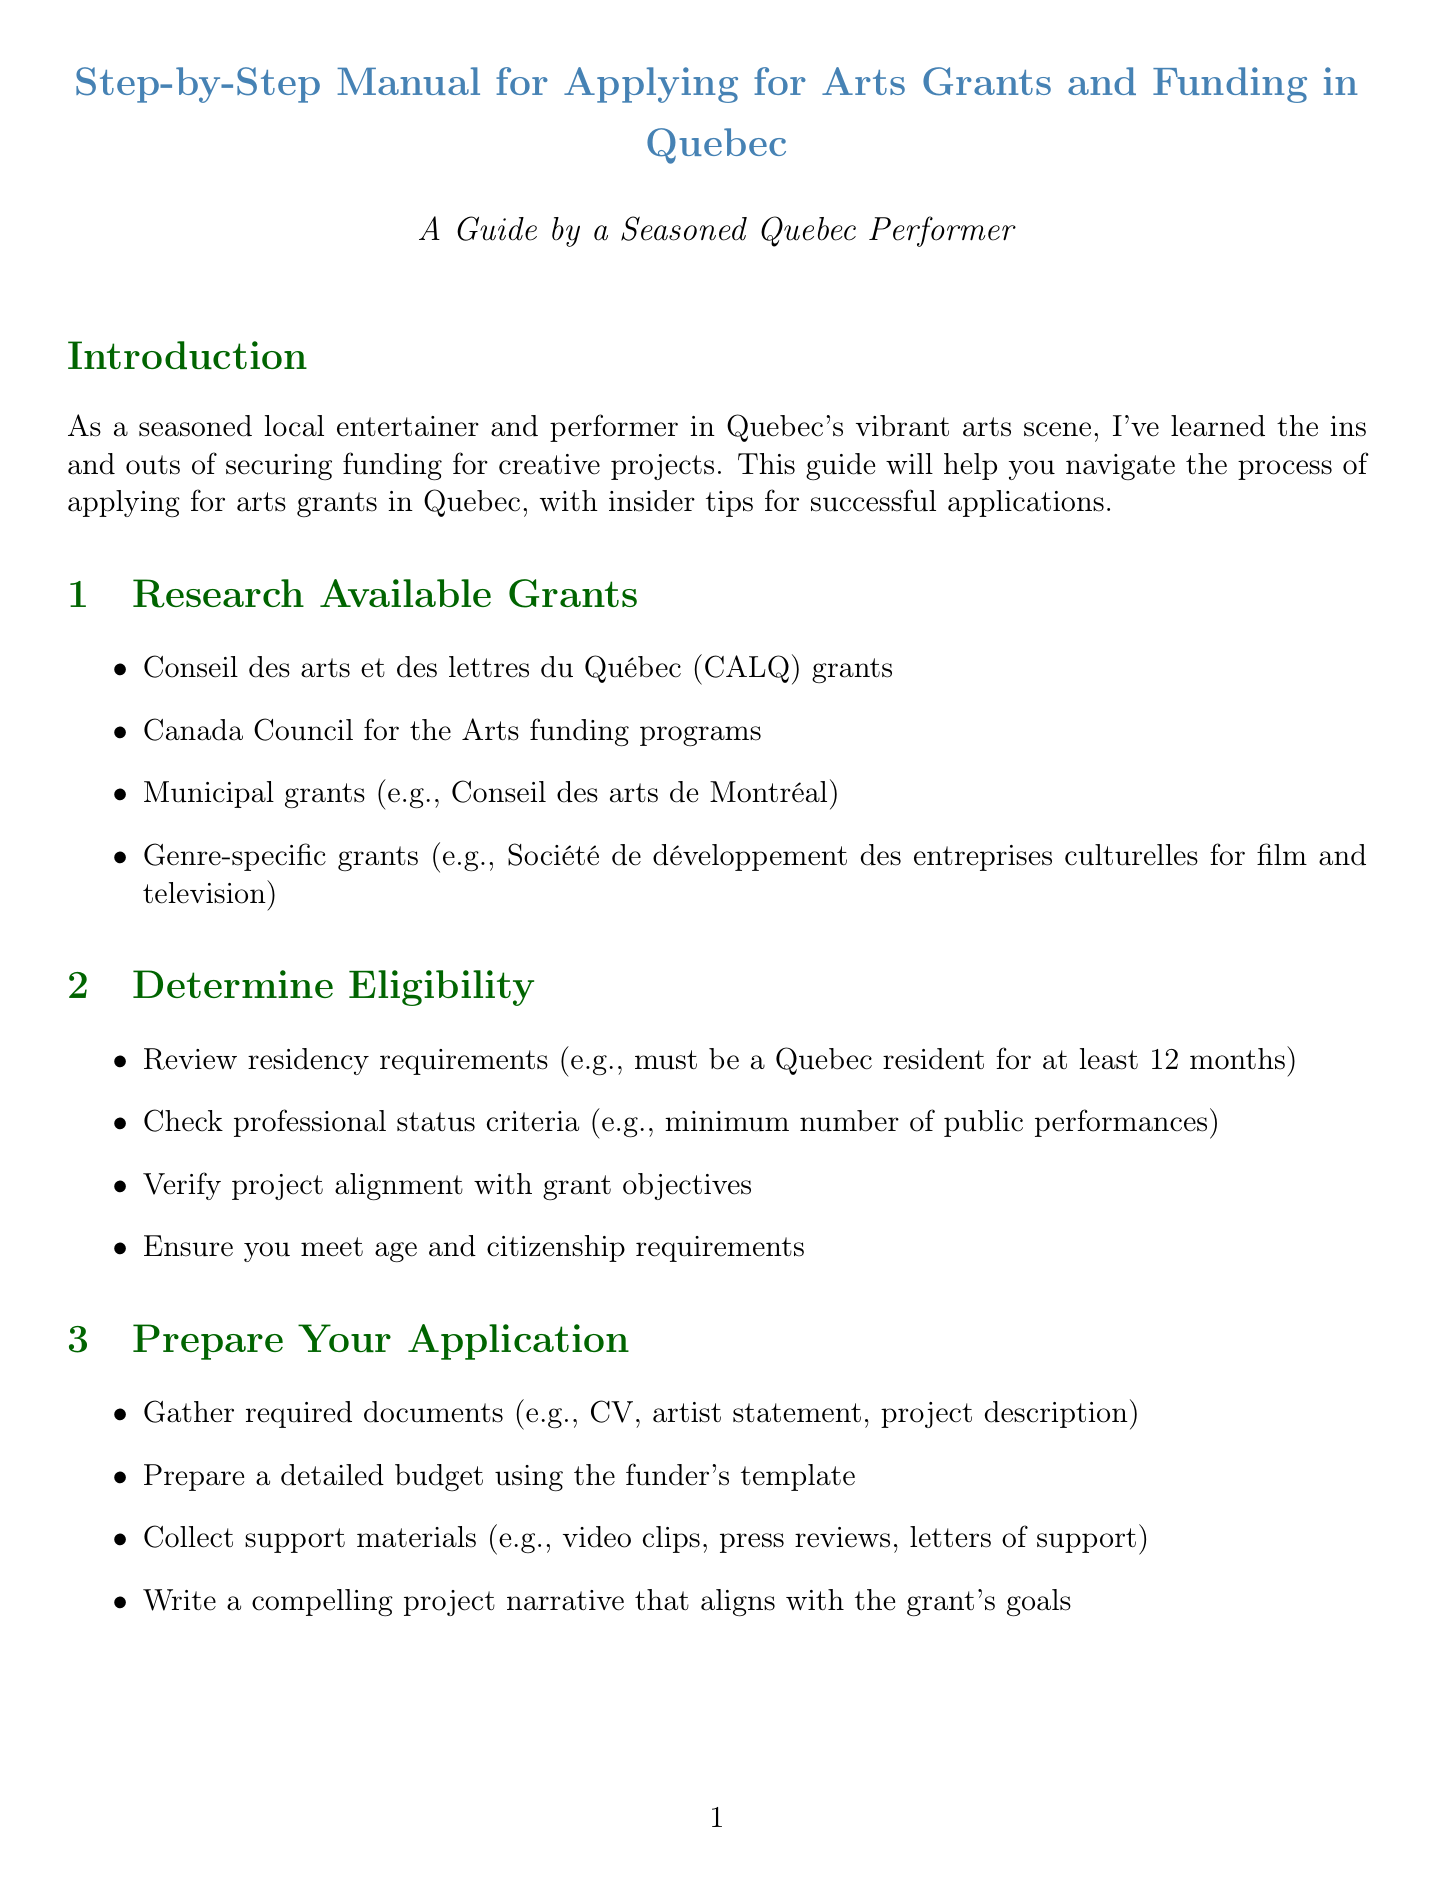What organization offers CALQ grants? The document lists Conseil des arts et des lettres du Québec (CALQ) as an available grant resource.
Answer: Conseil des arts et des lettres du Québec What is required for residency eligibility? The document states that applicants must be Quebec residents for at least 12 months to be eligible.
Answer: 12 months What should be gathered for the application? The document specifies that required documents include CV, artist statement, and project description.
Answer: CV, artist statement, project description What is the deadline for CALQ applications? The document mentions a specific submission deadline for many CALQ programs.
Answer: March 15th What should you do if your application is rejected? The document advises requesting feedback and applying again in the next cycle if rejected.
Answer: Request feedback and apply again How long before the deadline should you start preparing? The manual suggests starting preparation at least a specific number of months ahead of the deadline.
Answer: 2-3 months What is a resource offered for grant writing? The document mentions workshops offered by an organization as a resource for improving grant writing skills.
Answer: Culture Montréal What must you do after receiving a successful grant? The document states that you should carefully review the grant agreement if you are successful.
Answer: Review the grant agreement 